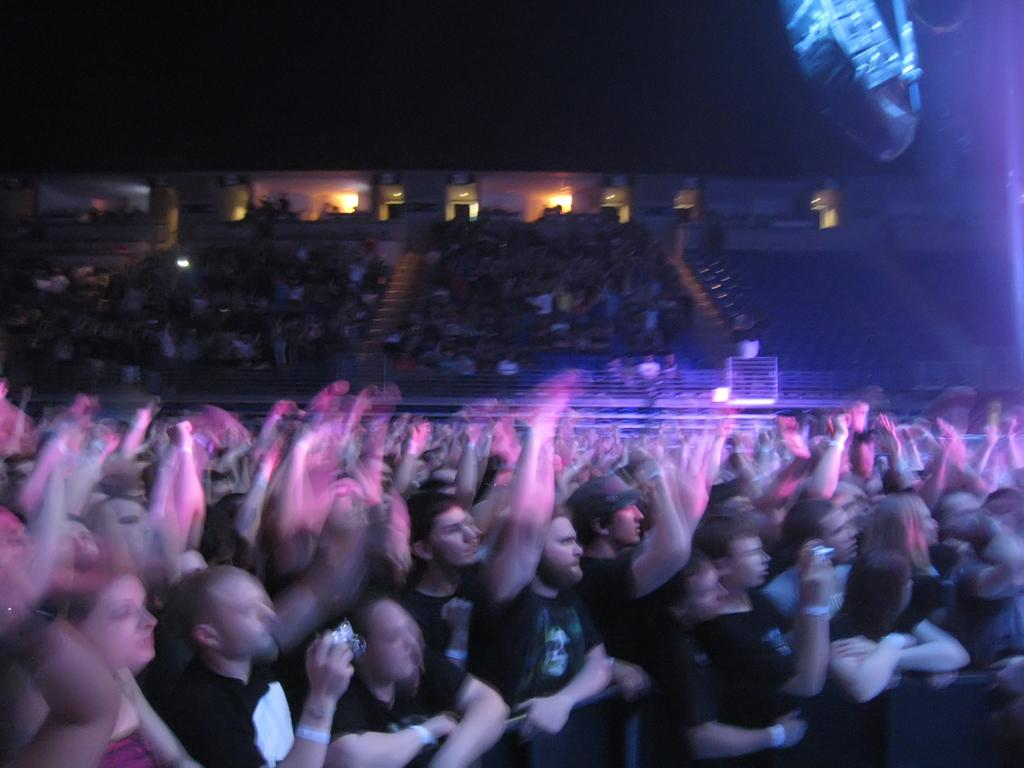How many people are in the image? There is a group of people in the image. What can be observed about the background in the image? The background is dark, and there are lights visible in the background. What type of structure can be seen in the background? There is a wall in the background. What type of soda is being sold at the market in the image? There is no market or soda present in the image; it features a group of people with a dark background and a visible wall. What color is the sheet draped over the table in the image? There is no sheet present in the image. 